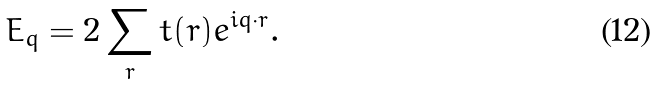<formula> <loc_0><loc_0><loc_500><loc_500>E _ { q } = 2 \sum _ { r } t ( { r } ) e ^ { i { q } \cdot { r } } .</formula> 